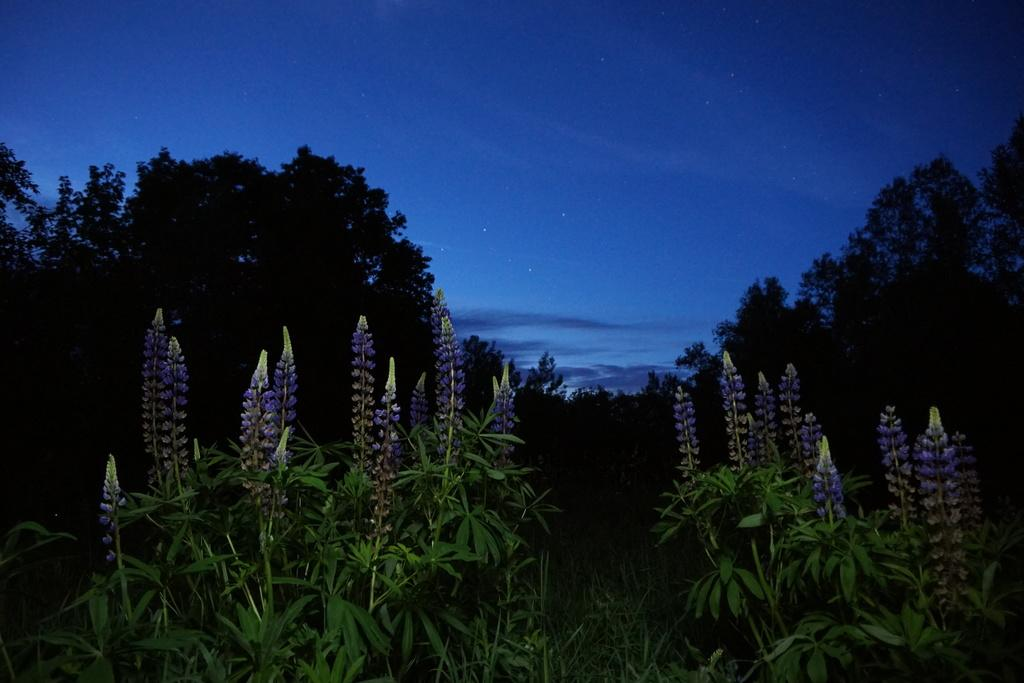What type of vegetation is in the front of the image? There are plants in the front of the image. What can be seen in the background of the image? There are trees, stars, clouds, and the sky visible in the background of the image. Can you see any goats grazing among the plants in the image? There are no goats present in the image; it only features plants in the front and various elements in the background. Are there any giants visible in the image? There are no giants present in the image. 